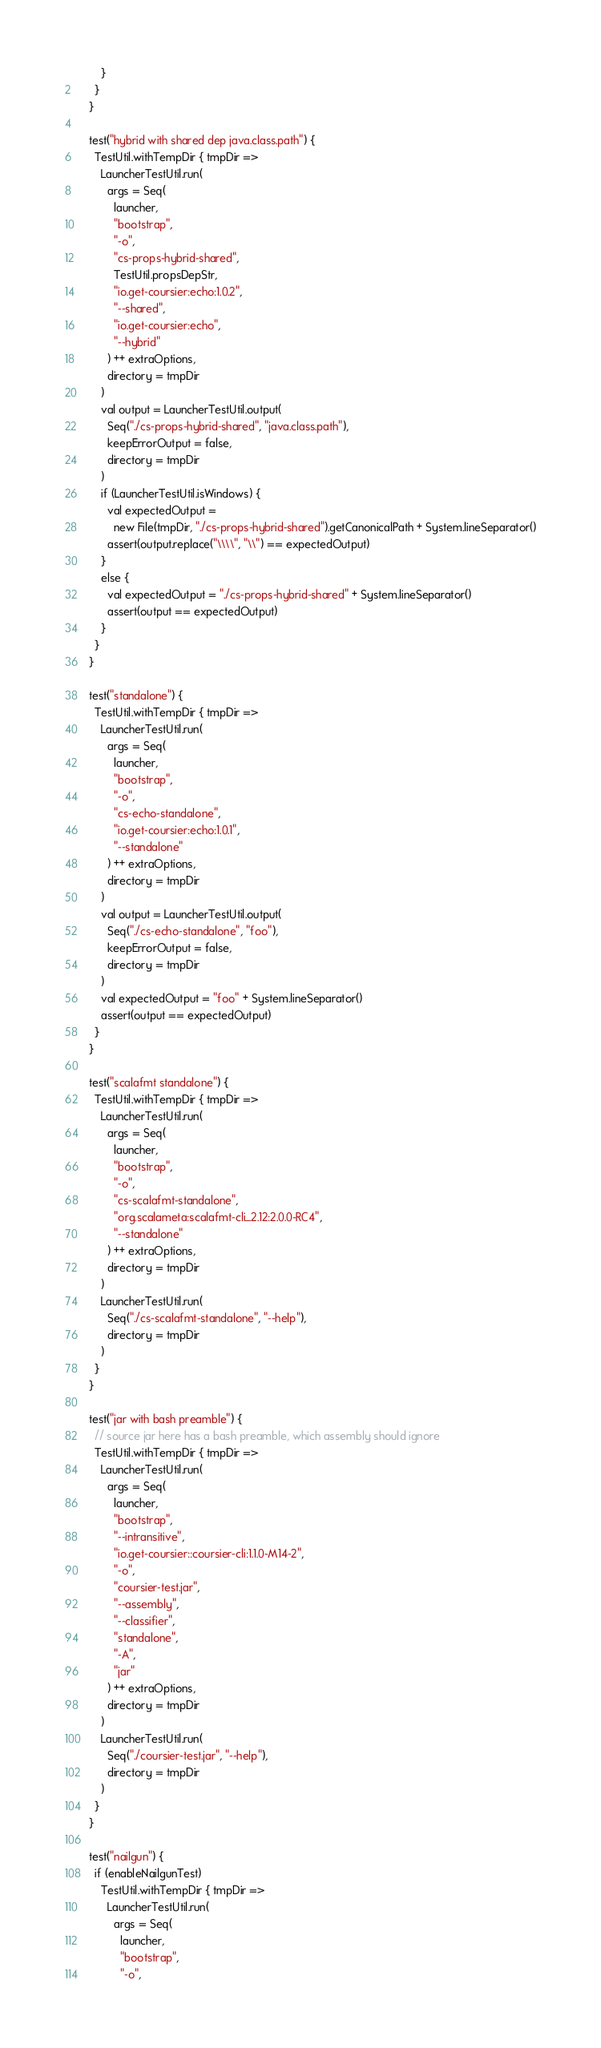Convert code to text. <code><loc_0><loc_0><loc_500><loc_500><_Scala_>        }
      }
    }

    test("hybrid with shared dep java.class.path") {
      TestUtil.withTempDir { tmpDir =>
        LauncherTestUtil.run(
          args = Seq(
            launcher,
            "bootstrap",
            "-o",
            "cs-props-hybrid-shared",
            TestUtil.propsDepStr,
            "io.get-coursier:echo:1.0.2",
            "--shared",
            "io.get-coursier:echo",
            "--hybrid"
          ) ++ extraOptions,
          directory = tmpDir
        )
        val output = LauncherTestUtil.output(
          Seq("./cs-props-hybrid-shared", "java.class.path"),
          keepErrorOutput = false,
          directory = tmpDir
        )
        if (LauncherTestUtil.isWindows) {
          val expectedOutput =
            new File(tmpDir, "./cs-props-hybrid-shared").getCanonicalPath + System.lineSeparator()
          assert(output.replace("\\\\", "\\") == expectedOutput)
        }
        else {
          val expectedOutput = "./cs-props-hybrid-shared" + System.lineSeparator()
          assert(output == expectedOutput)
        }
      }
    }

    test("standalone") {
      TestUtil.withTempDir { tmpDir =>
        LauncherTestUtil.run(
          args = Seq(
            launcher,
            "bootstrap",
            "-o",
            "cs-echo-standalone",
            "io.get-coursier:echo:1.0.1",
            "--standalone"
          ) ++ extraOptions,
          directory = tmpDir
        )
        val output = LauncherTestUtil.output(
          Seq("./cs-echo-standalone", "foo"),
          keepErrorOutput = false,
          directory = tmpDir
        )
        val expectedOutput = "foo" + System.lineSeparator()
        assert(output == expectedOutput)
      }
    }

    test("scalafmt standalone") {
      TestUtil.withTempDir { tmpDir =>
        LauncherTestUtil.run(
          args = Seq(
            launcher,
            "bootstrap",
            "-o",
            "cs-scalafmt-standalone",
            "org.scalameta:scalafmt-cli_2.12:2.0.0-RC4",
            "--standalone"
          ) ++ extraOptions,
          directory = tmpDir
        )
        LauncherTestUtil.run(
          Seq("./cs-scalafmt-standalone", "--help"),
          directory = tmpDir
        )
      }
    }

    test("jar with bash preamble") {
      // source jar here has a bash preamble, which assembly should ignore
      TestUtil.withTempDir { tmpDir =>
        LauncherTestUtil.run(
          args = Seq(
            launcher,
            "bootstrap",
            "--intransitive",
            "io.get-coursier::coursier-cli:1.1.0-M14-2",
            "-o",
            "coursier-test.jar",
            "--assembly",
            "--classifier",
            "standalone",
            "-A",
            "jar"
          ) ++ extraOptions,
          directory = tmpDir
        )
        LauncherTestUtil.run(
          Seq("./coursier-test.jar", "--help"),
          directory = tmpDir
        )
      }
    }

    test("nailgun") {
      if (enableNailgunTest)
        TestUtil.withTempDir { tmpDir =>
          LauncherTestUtil.run(
            args = Seq(
              launcher,
              "bootstrap",
              "-o",</code> 